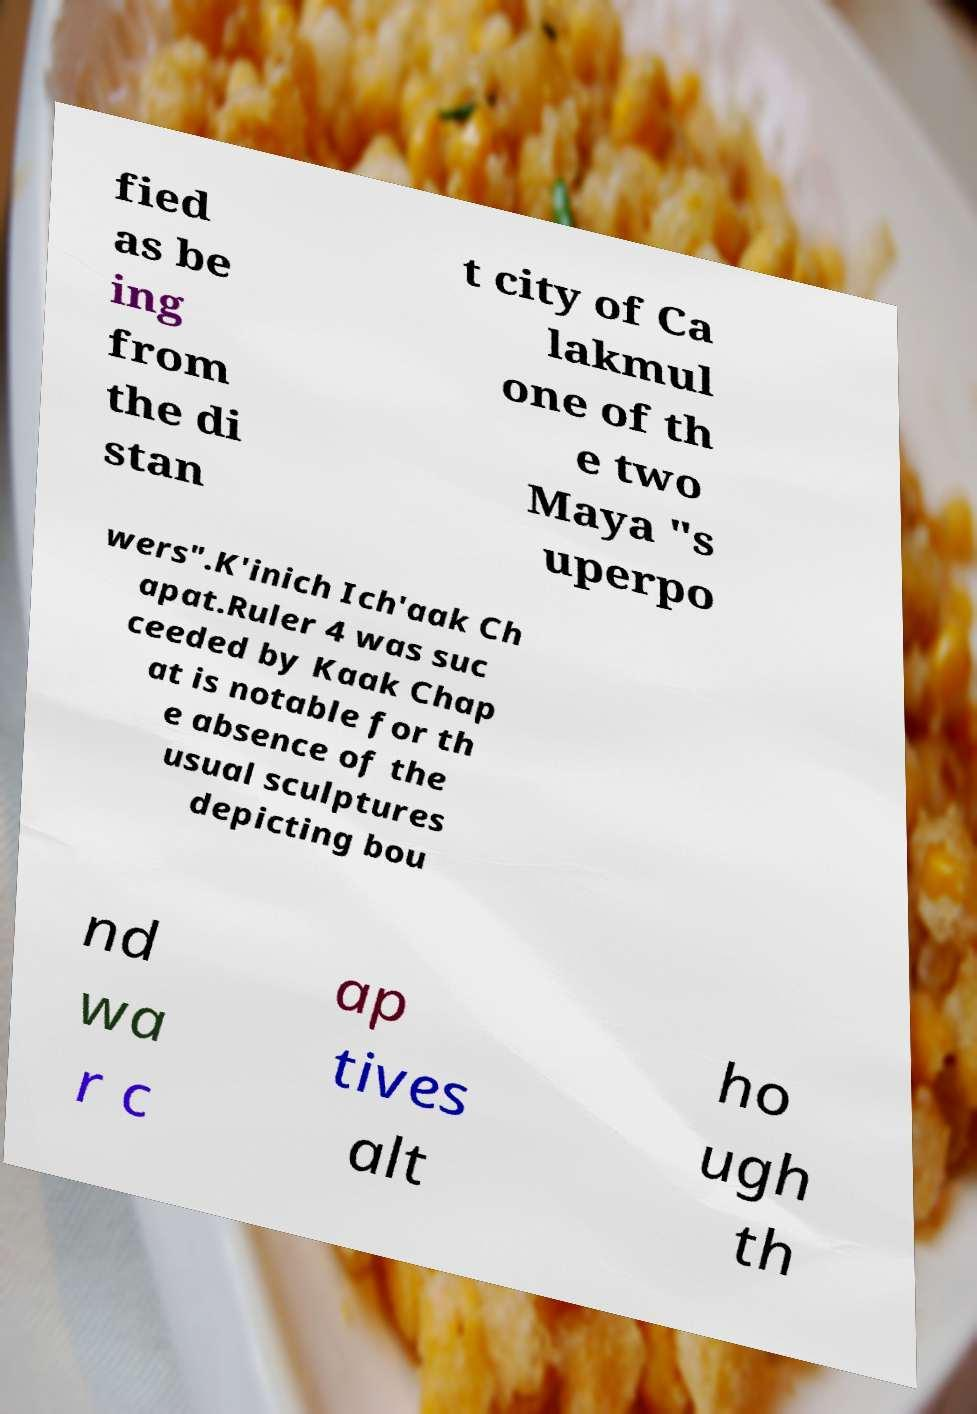Please identify and transcribe the text found in this image. fied as be ing from the di stan t city of Ca lakmul one of th e two Maya "s uperpo wers".K'inich Ich'aak Ch apat.Ruler 4 was suc ceeded by Kaak Chap at is notable for th e absence of the usual sculptures depicting bou nd wa r c ap tives alt ho ugh th 